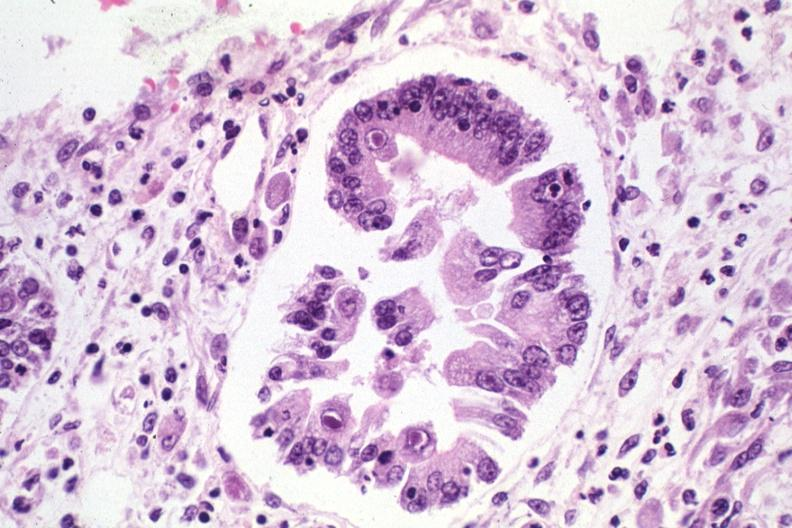what is present?
Answer the question using a single word or phrase. Stomach 